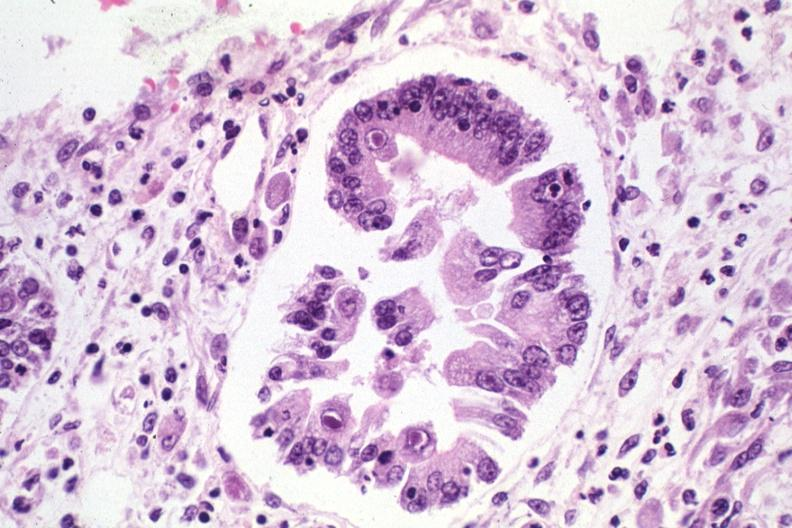what is present?
Answer the question using a single word or phrase. Stomach 